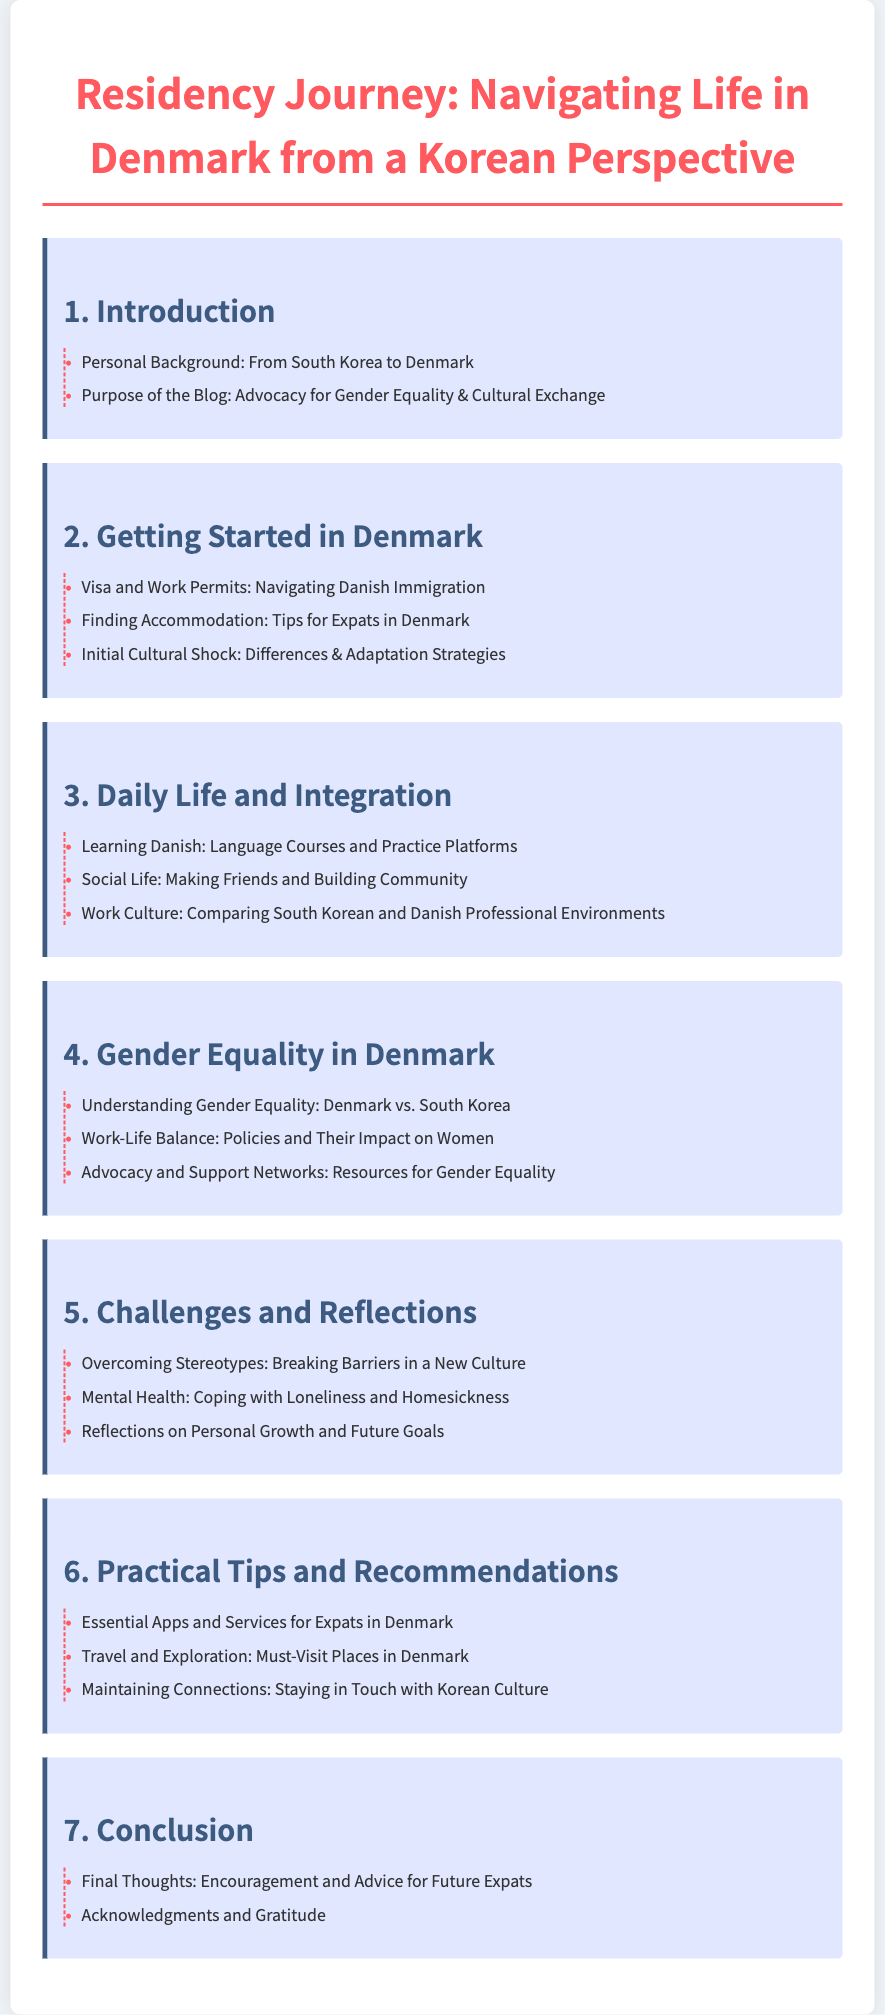what is the title of the document? The title of the document is prominently displayed in the header section of the rendered content.
Answer: Residency Journey: Navigating Life in Denmark from a Korean Perspective how many chapters are in the document? The number of chapters can be counted from the table of contents where each chapter is listed.
Answer: 7 what is the first section under the chapter "Challenges and Reflections"? The sections are clearly listed under each chapter. The first section under "Challenges and Reflections" can be found there.
Answer: Overcoming Stereotypes: Breaking Barriers in a New Culture which chapter discusses gender equality? The chapter titles provide insight into the topics covered, and gender equality is explicitly mentioned in one of the chapter titles.
Answer: 4 what is a recommended resource mentioned in the chapter on Gender Equality? The sections in this chapter outline specific resources related to gender equality in Denmark.
Answer: Advocacy and Support Networks: Resources for Gender Equality what is the purpose of the blog? The purpose is outlined clearly in the introduction section of the document.
Answer: Advocacy for Gender Equality & Cultural Exchange how does the document categorize social life experiences? The daily life chapter provides different aspects of social integration and is categorized under that topic.
Answer: Making Friends and Building Community 